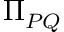<formula> <loc_0><loc_0><loc_500><loc_500>\Pi _ { P Q }</formula> 